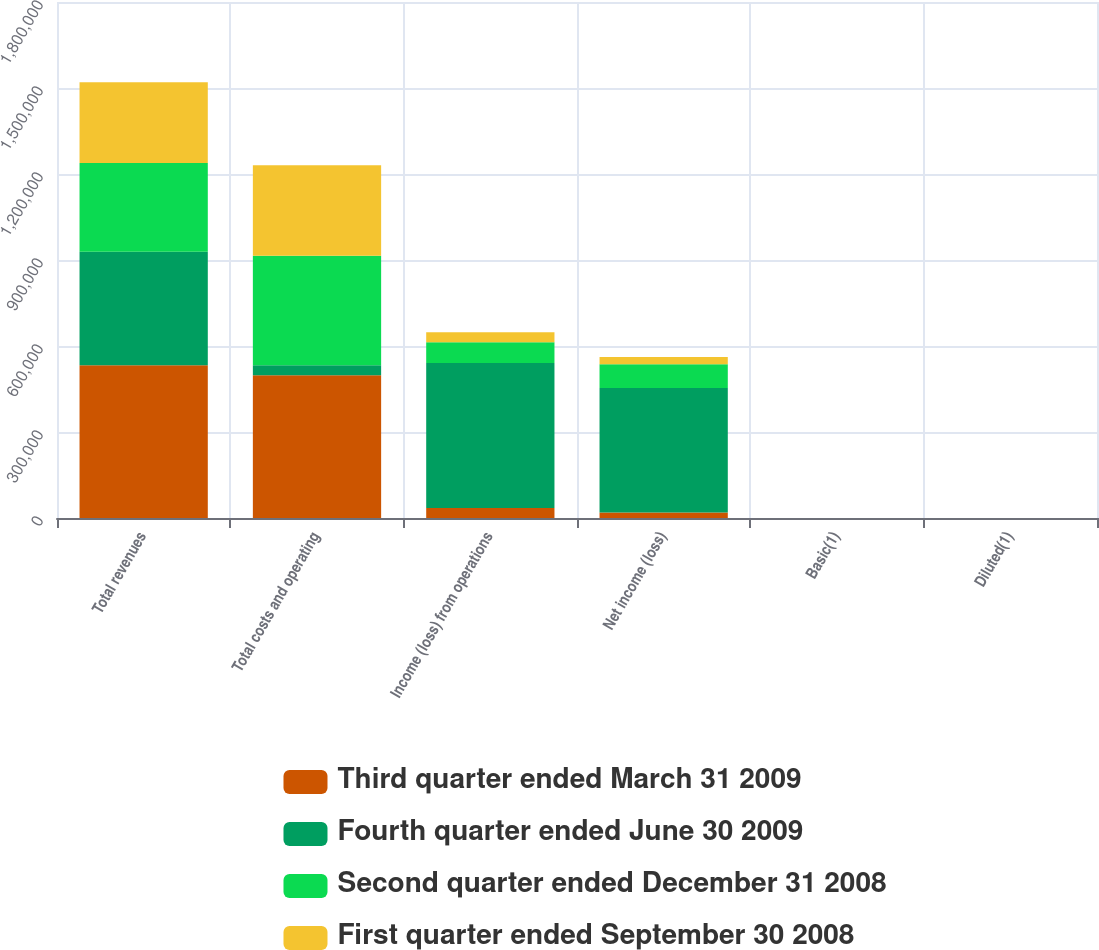Convert chart. <chart><loc_0><loc_0><loc_500><loc_500><stacked_bar_chart><ecel><fcel>Total revenues<fcel>Total costs and operating<fcel>Income (loss) from operations<fcel>Net income (loss)<fcel>Basic(1)<fcel>Diluted(1)<nl><fcel>Third quarter ended March 31 2009<fcel>532513<fcel>497575<fcel>34938<fcel>19289<fcel>0.11<fcel>0.11<nl><fcel>Fourth quarter ended June 30 2009<fcel>396589<fcel>34967<fcel>505631<fcel>434254<fcel>2.57<fcel>2.57<nl><fcel>Second quarter ended December 31 2008<fcel>309612<fcel>381893<fcel>72281<fcel>82827<fcel>0.49<fcel>0.49<nl><fcel>First quarter ended September 30 2008<fcel>281502<fcel>316469<fcel>34967<fcel>25576<fcel>0.15<fcel>0.15<nl></chart> 